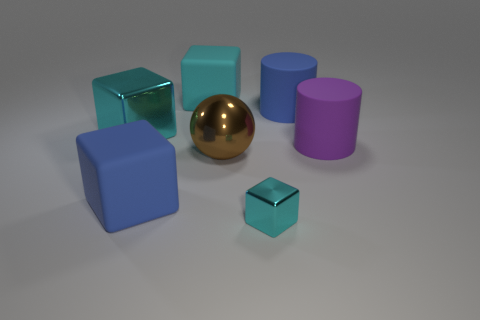There is a shiny object that is the same color as the big metal block; what is its size?
Your answer should be very brief. Small. Do the cyan matte object and the purple thing have the same shape?
Offer a terse response. No. What is the material of the big cube that is right of the big cyan metal cube and in front of the cyan matte block?
Make the answer very short. Rubber. There is another rubber object that is the same shape as the cyan matte object; what color is it?
Offer a terse response. Blue. Are there any other things that have the same color as the tiny block?
Give a very brief answer. Yes. There is a blue matte thing that is to the left of the large cyan rubber cube; is its size the same as the cyan cube on the left side of the cyan rubber block?
Your answer should be compact. Yes. Are there an equal number of large brown spheres right of the purple object and shiny cubes that are in front of the large brown shiny thing?
Keep it short and to the point. No. There is a cyan rubber object; is it the same size as the metallic object in front of the metallic ball?
Your answer should be very brief. No. Are there any cubes that are in front of the blue rubber thing on the right side of the small cyan metallic cube?
Give a very brief answer. Yes. Are there any large cyan objects that have the same shape as the purple rubber thing?
Provide a succinct answer. No. 